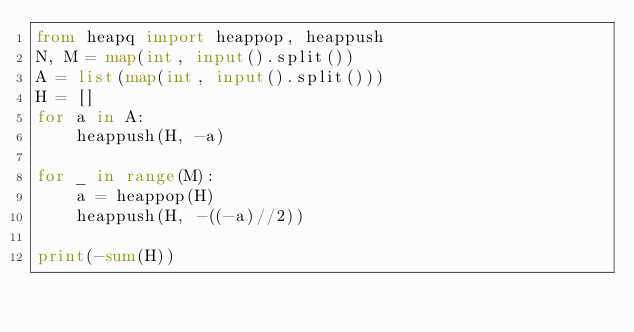<code> <loc_0><loc_0><loc_500><loc_500><_Python_>from heapq import heappop, heappush
N, M = map(int, input().split())
A = list(map(int, input().split()))
H = []
for a in A:
    heappush(H, -a)

for _ in range(M):
    a = heappop(H)
    heappush(H, -((-a)//2))

print(-sum(H))</code> 